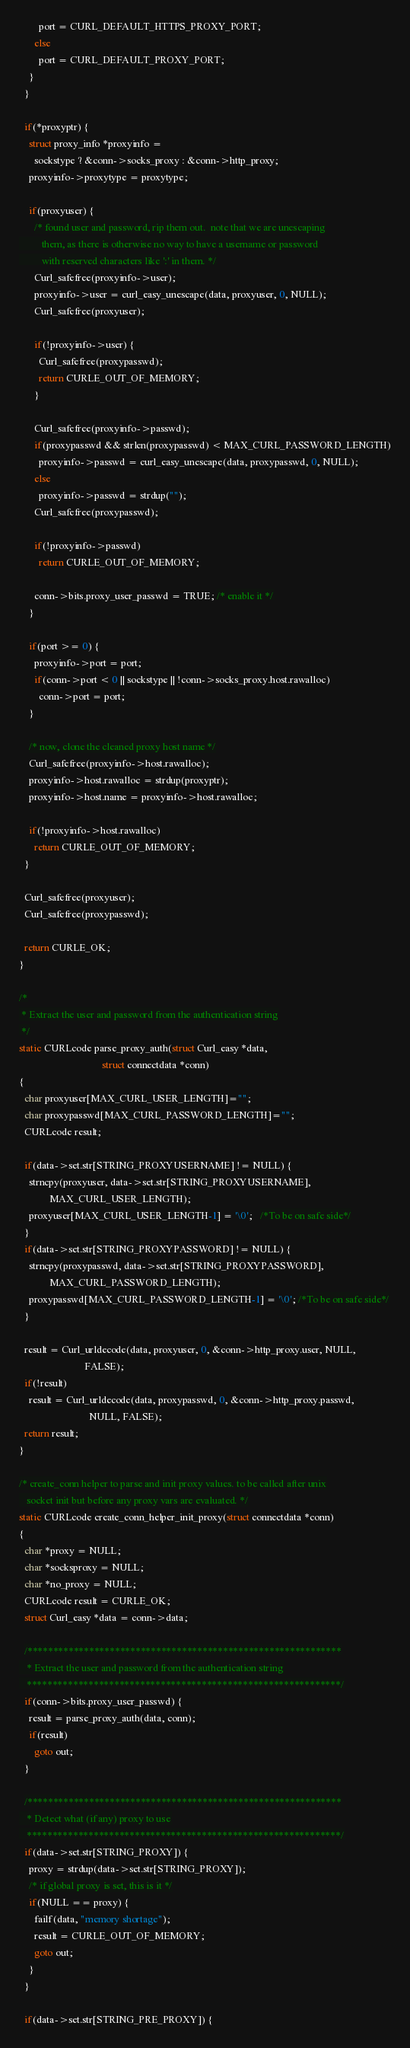<code> <loc_0><loc_0><loc_500><loc_500><_C_>        port = CURL_DEFAULT_HTTPS_PROXY_PORT;
      else
        port = CURL_DEFAULT_PROXY_PORT;
    }
  }

  if(*proxyptr) {
    struct proxy_info *proxyinfo =
      sockstype ? &conn->socks_proxy : &conn->http_proxy;
    proxyinfo->proxytype = proxytype;

    if(proxyuser) {
      /* found user and password, rip them out.  note that we are unescaping
         them, as there is otherwise no way to have a username or password
         with reserved characters like ':' in them. */
      Curl_safefree(proxyinfo->user);
      proxyinfo->user = curl_easy_unescape(data, proxyuser, 0, NULL);
      Curl_safefree(proxyuser);

      if(!proxyinfo->user) {
        Curl_safefree(proxypasswd);
        return CURLE_OUT_OF_MEMORY;
      }

      Curl_safefree(proxyinfo->passwd);
      if(proxypasswd && strlen(proxypasswd) < MAX_CURL_PASSWORD_LENGTH)
        proxyinfo->passwd = curl_easy_unescape(data, proxypasswd, 0, NULL);
      else
        proxyinfo->passwd = strdup("");
      Curl_safefree(proxypasswd);

      if(!proxyinfo->passwd)
        return CURLE_OUT_OF_MEMORY;

      conn->bits.proxy_user_passwd = TRUE; /* enable it */
    }

    if(port >= 0) {
      proxyinfo->port = port;
      if(conn->port < 0 || sockstype || !conn->socks_proxy.host.rawalloc)
        conn->port = port;
    }

    /* now, clone the cleaned proxy host name */
    Curl_safefree(proxyinfo->host.rawalloc);
    proxyinfo->host.rawalloc = strdup(proxyptr);
    proxyinfo->host.name = proxyinfo->host.rawalloc;

    if(!proxyinfo->host.rawalloc)
      return CURLE_OUT_OF_MEMORY;
  }

  Curl_safefree(proxyuser);
  Curl_safefree(proxypasswd);

  return CURLE_OK;
}

/*
 * Extract the user and password from the authentication string
 */
static CURLcode parse_proxy_auth(struct Curl_easy *data,
                                 struct connectdata *conn)
{
  char proxyuser[MAX_CURL_USER_LENGTH]="";
  char proxypasswd[MAX_CURL_PASSWORD_LENGTH]="";
  CURLcode result;

  if(data->set.str[STRING_PROXYUSERNAME] != NULL) {
    strncpy(proxyuser, data->set.str[STRING_PROXYUSERNAME],
            MAX_CURL_USER_LENGTH);
    proxyuser[MAX_CURL_USER_LENGTH-1] = '\0';   /*To be on safe side*/
  }
  if(data->set.str[STRING_PROXYPASSWORD] != NULL) {
    strncpy(proxypasswd, data->set.str[STRING_PROXYPASSWORD],
            MAX_CURL_PASSWORD_LENGTH);
    proxypasswd[MAX_CURL_PASSWORD_LENGTH-1] = '\0'; /*To be on safe side*/
  }

  result = Curl_urldecode(data, proxyuser, 0, &conn->http_proxy.user, NULL,
                          FALSE);
  if(!result)
    result = Curl_urldecode(data, proxypasswd, 0, &conn->http_proxy.passwd,
                            NULL, FALSE);
  return result;
}

/* create_conn helper to parse and init proxy values. to be called after unix
   socket init but before any proxy vars are evaluated. */
static CURLcode create_conn_helper_init_proxy(struct connectdata *conn)
{
  char *proxy = NULL;
  char *socksproxy = NULL;
  char *no_proxy = NULL;
  CURLcode result = CURLE_OK;
  struct Curl_easy *data = conn->data;

  /*************************************************************
   * Extract the user and password from the authentication string
   *************************************************************/
  if(conn->bits.proxy_user_passwd) {
    result = parse_proxy_auth(data, conn);
    if(result)
      goto out;
  }

  /*************************************************************
   * Detect what (if any) proxy to use
   *************************************************************/
  if(data->set.str[STRING_PROXY]) {
    proxy = strdup(data->set.str[STRING_PROXY]);
    /* if global proxy is set, this is it */
    if(NULL == proxy) {
      failf(data, "memory shortage");
      result = CURLE_OUT_OF_MEMORY;
      goto out;
    }
  }

  if(data->set.str[STRING_PRE_PROXY]) {</code> 